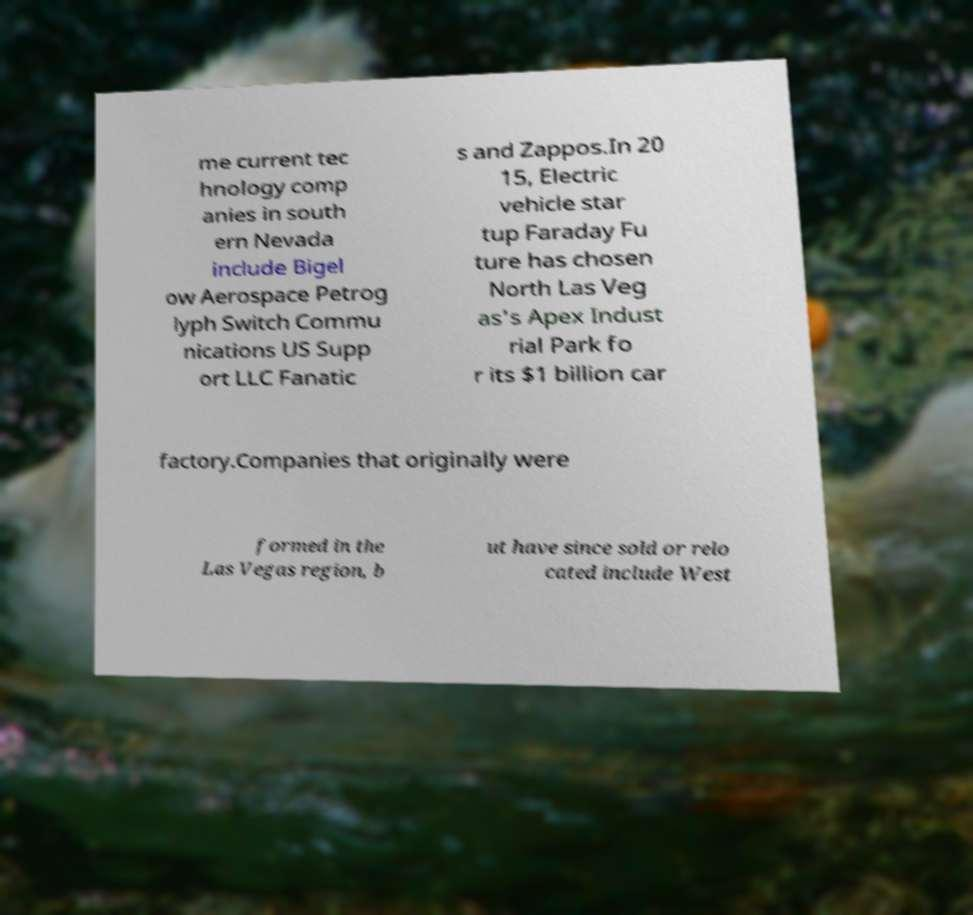Please read and relay the text visible in this image. What does it say? me current tec hnology comp anies in south ern Nevada include Bigel ow Aerospace Petrog lyph Switch Commu nications US Supp ort LLC Fanatic s and Zappos.In 20 15, Electric vehicle star tup Faraday Fu ture has chosen North Las Veg as's Apex Indust rial Park fo r its $1 billion car factory.Companies that originally were formed in the Las Vegas region, b ut have since sold or relo cated include West 